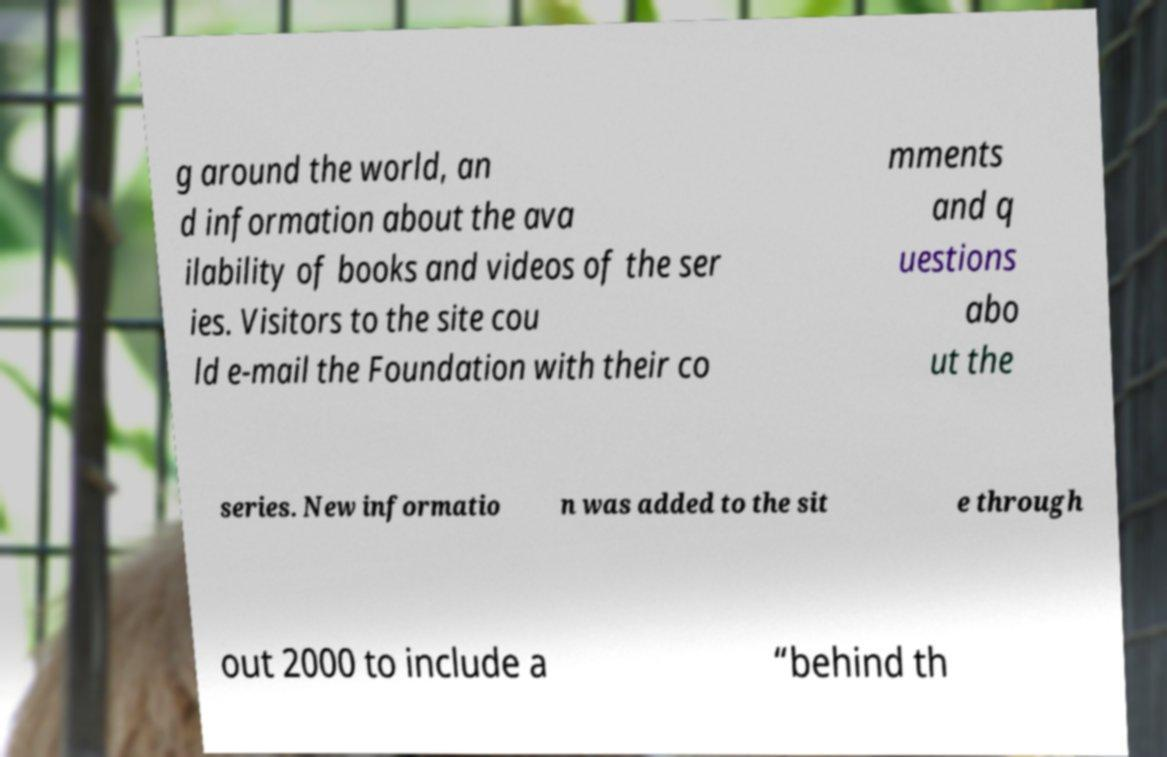What messages or text are displayed in this image? I need them in a readable, typed format. g around the world, an d information about the ava ilability of books and videos of the ser ies. Visitors to the site cou ld e-mail the Foundation with their co mments and q uestions abo ut the series. New informatio n was added to the sit e through out 2000 to include a “behind th 